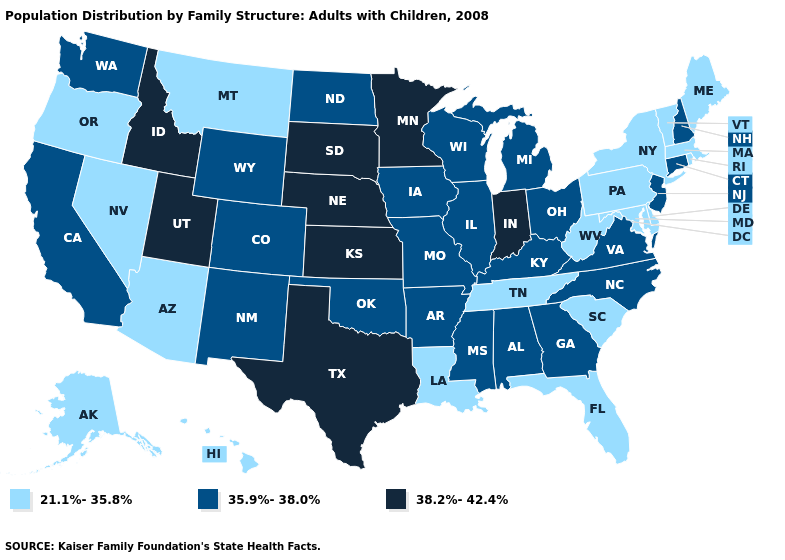Name the states that have a value in the range 21.1%-35.8%?
Concise answer only. Alaska, Arizona, Delaware, Florida, Hawaii, Louisiana, Maine, Maryland, Massachusetts, Montana, Nevada, New York, Oregon, Pennsylvania, Rhode Island, South Carolina, Tennessee, Vermont, West Virginia. Name the states that have a value in the range 38.2%-42.4%?
Answer briefly. Idaho, Indiana, Kansas, Minnesota, Nebraska, South Dakota, Texas, Utah. What is the value of Arizona?
Quick response, please. 21.1%-35.8%. Among the states that border Nebraska , which have the lowest value?
Concise answer only. Colorado, Iowa, Missouri, Wyoming. Name the states that have a value in the range 35.9%-38.0%?
Be succinct. Alabama, Arkansas, California, Colorado, Connecticut, Georgia, Illinois, Iowa, Kentucky, Michigan, Mississippi, Missouri, New Hampshire, New Jersey, New Mexico, North Carolina, North Dakota, Ohio, Oklahoma, Virginia, Washington, Wisconsin, Wyoming. What is the value of Pennsylvania?
Concise answer only. 21.1%-35.8%. What is the value of Arkansas?
Keep it brief. 35.9%-38.0%. What is the highest value in states that border Kentucky?
Short answer required. 38.2%-42.4%. Name the states that have a value in the range 38.2%-42.4%?
Quick response, please. Idaho, Indiana, Kansas, Minnesota, Nebraska, South Dakota, Texas, Utah. What is the value of Delaware?
Answer briefly. 21.1%-35.8%. Name the states that have a value in the range 21.1%-35.8%?
Keep it brief. Alaska, Arizona, Delaware, Florida, Hawaii, Louisiana, Maine, Maryland, Massachusetts, Montana, Nevada, New York, Oregon, Pennsylvania, Rhode Island, South Carolina, Tennessee, Vermont, West Virginia. Name the states that have a value in the range 35.9%-38.0%?
Short answer required. Alabama, Arkansas, California, Colorado, Connecticut, Georgia, Illinois, Iowa, Kentucky, Michigan, Mississippi, Missouri, New Hampshire, New Jersey, New Mexico, North Carolina, North Dakota, Ohio, Oklahoma, Virginia, Washington, Wisconsin, Wyoming. Does New Hampshire have the same value as Mississippi?
Write a very short answer. Yes. Name the states that have a value in the range 38.2%-42.4%?
Answer briefly. Idaho, Indiana, Kansas, Minnesota, Nebraska, South Dakota, Texas, Utah. Name the states that have a value in the range 21.1%-35.8%?
Answer briefly. Alaska, Arizona, Delaware, Florida, Hawaii, Louisiana, Maine, Maryland, Massachusetts, Montana, Nevada, New York, Oregon, Pennsylvania, Rhode Island, South Carolina, Tennessee, Vermont, West Virginia. 